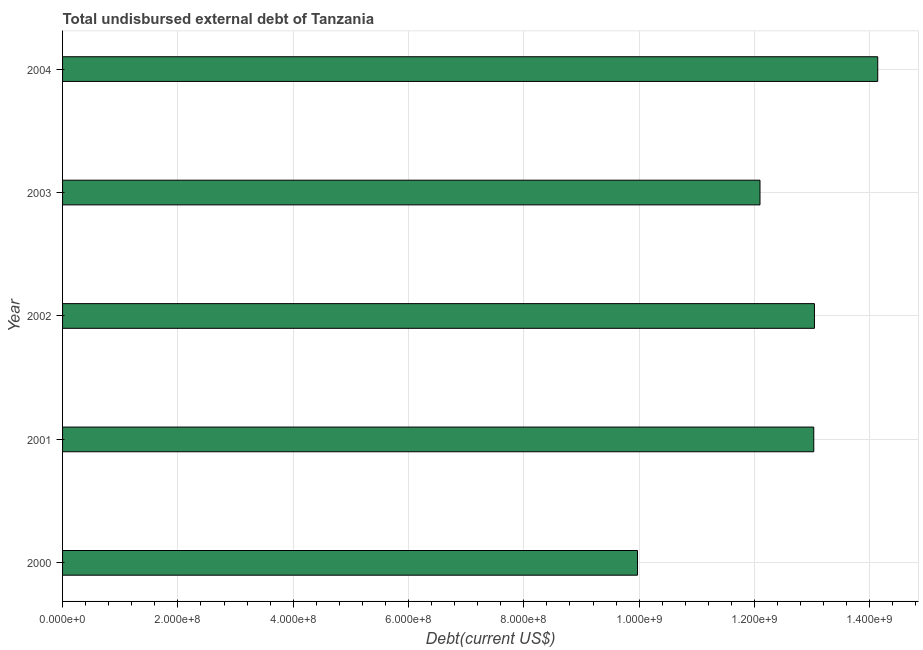Does the graph contain any zero values?
Your answer should be compact. No. Does the graph contain grids?
Ensure brevity in your answer.  Yes. What is the title of the graph?
Ensure brevity in your answer.  Total undisbursed external debt of Tanzania. What is the label or title of the X-axis?
Your answer should be compact. Debt(current US$). What is the total debt in 2002?
Your answer should be very brief. 1.30e+09. Across all years, what is the maximum total debt?
Your answer should be compact. 1.41e+09. Across all years, what is the minimum total debt?
Your answer should be very brief. 9.97e+08. What is the sum of the total debt?
Your response must be concise. 6.23e+09. What is the difference between the total debt in 2002 and 2004?
Ensure brevity in your answer.  -1.10e+08. What is the average total debt per year?
Give a very brief answer. 1.25e+09. What is the median total debt?
Provide a short and direct response. 1.30e+09. In how many years, is the total debt greater than 160000000 US$?
Give a very brief answer. 5. What is the ratio of the total debt in 2000 to that in 2002?
Provide a short and direct response. 0.77. Is the total debt in 2000 less than that in 2003?
Offer a terse response. Yes. What is the difference between the highest and the second highest total debt?
Your response must be concise. 1.10e+08. Is the sum of the total debt in 2002 and 2004 greater than the maximum total debt across all years?
Keep it short and to the point. Yes. What is the difference between the highest and the lowest total debt?
Your answer should be very brief. 4.17e+08. Are all the bars in the graph horizontal?
Offer a very short reply. Yes. How many years are there in the graph?
Ensure brevity in your answer.  5. What is the difference between two consecutive major ticks on the X-axis?
Your answer should be compact. 2.00e+08. What is the Debt(current US$) of 2000?
Make the answer very short. 9.97e+08. What is the Debt(current US$) in 2001?
Offer a very short reply. 1.30e+09. What is the Debt(current US$) in 2002?
Ensure brevity in your answer.  1.30e+09. What is the Debt(current US$) of 2003?
Your answer should be very brief. 1.21e+09. What is the Debt(current US$) in 2004?
Give a very brief answer. 1.41e+09. What is the difference between the Debt(current US$) in 2000 and 2001?
Your answer should be compact. -3.06e+08. What is the difference between the Debt(current US$) in 2000 and 2002?
Make the answer very short. -3.07e+08. What is the difference between the Debt(current US$) in 2000 and 2003?
Your response must be concise. -2.12e+08. What is the difference between the Debt(current US$) in 2000 and 2004?
Your answer should be very brief. -4.17e+08. What is the difference between the Debt(current US$) in 2001 and 2002?
Your response must be concise. -1.18e+06. What is the difference between the Debt(current US$) in 2001 and 2003?
Give a very brief answer. 9.32e+07. What is the difference between the Debt(current US$) in 2001 and 2004?
Make the answer very short. -1.11e+08. What is the difference between the Debt(current US$) in 2002 and 2003?
Your response must be concise. 9.44e+07. What is the difference between the Debt(current US$) in 2002 and 2004?
Your response must be concise. -1.10e+08. What is the difference between the Debt(current US$) in 2003 and 2004?
Provide a succinct answer. -2.04e+08. What is the ratio of the Debt(current US$) in 2000 to that in 2001?
Make the answer very short. 0.77. What is the ratio of the Debt(current US$) in 2000 to that in 2002?
Provide a short and direct response. 0.77. What is the ratio of the Debt(current US$) in 2000 to that in 2003?
Your answer should be compact. 0.82. What is the ratio of the Debt(current US$) in 2000 to that in 2004?
Make the answer very short. 0.7. What is the ratio of the Debt(current US$) in 2001 to that in 2002?
Your answer should be very brief. 1. What is the ratio of the Debt(current US$) in 2001 to that in 2003?
Keep it short and to the point. 1.08. What is the ratio of the Debt(current US$) in 2001 to that in 2004?
Your answer should be very brief. 0.92. What is the ratio of the Debt(current US$) in 2002 to that in 2003?
Ensure brevity in your answer.  1.08. What is the ratio of the Debt(current US$) in 2002 to that in 2004?
Provide a short and direct response. 0.92. What is the ratio of the Debt(current US$) in 2003 to that in 2004?
Offer a terse response. 0.86. 